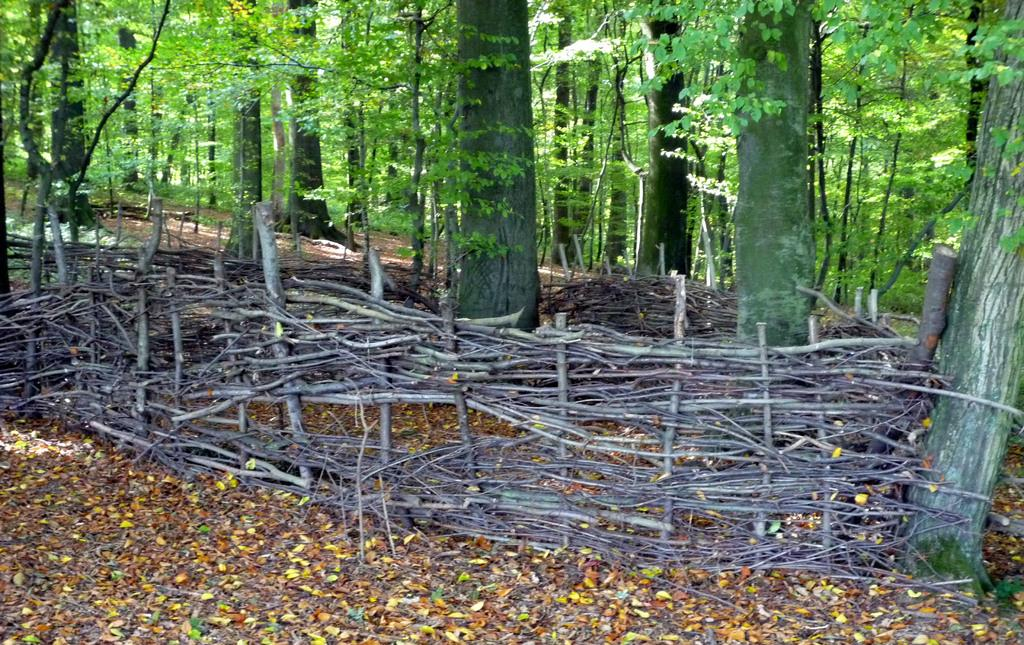What type of vegetation can be seen in the image? There are trees in the image. What structure is present in the image? There is a fence with sticks in the image. What can be found on the ground in the image? Leaves are present on the ground in the image. Where is the advertisement for cherries located in the image? There is no advertisement for cherries present in the image. What type of glue is being used to attach the leaves to the ground in the image? There is no glue present in the image; the leaves are naturally on the ground. 